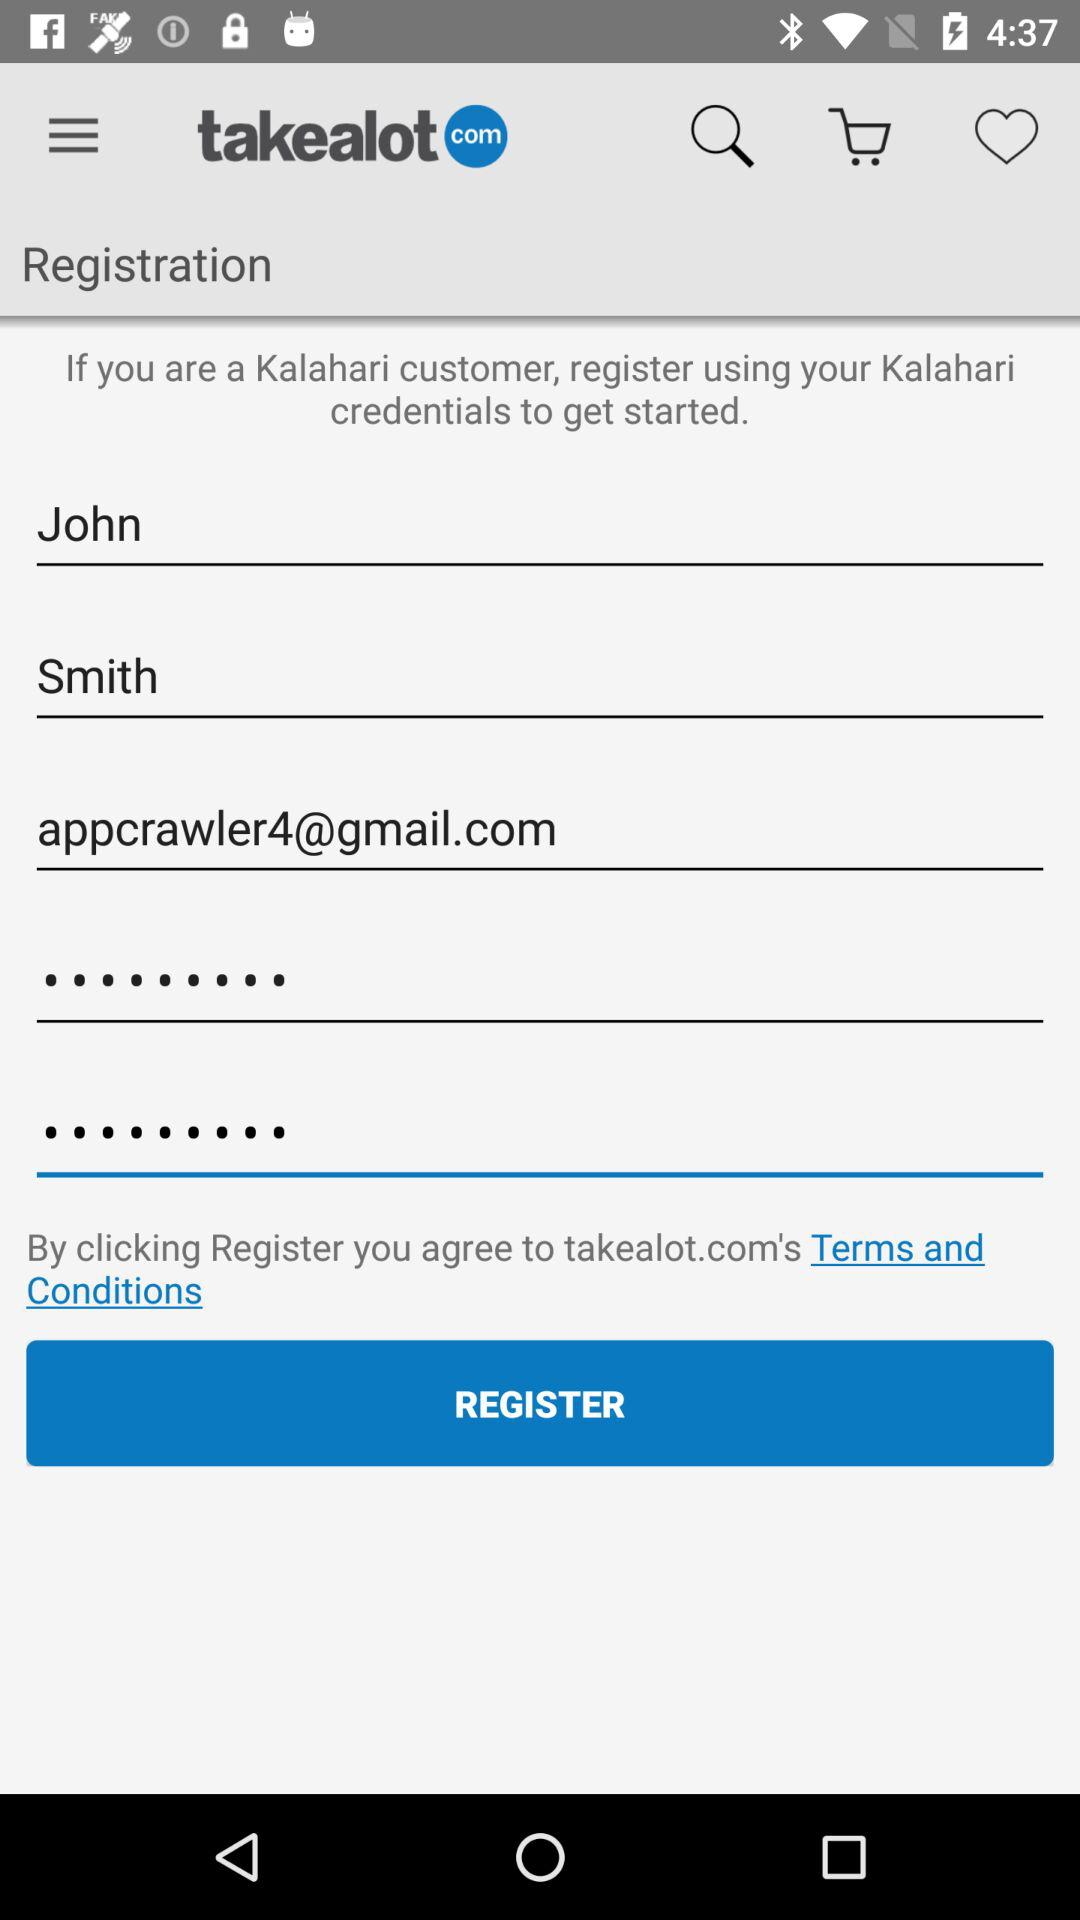What's the Gmail address? The Gmail address is appcrawler4@gmail.com. 